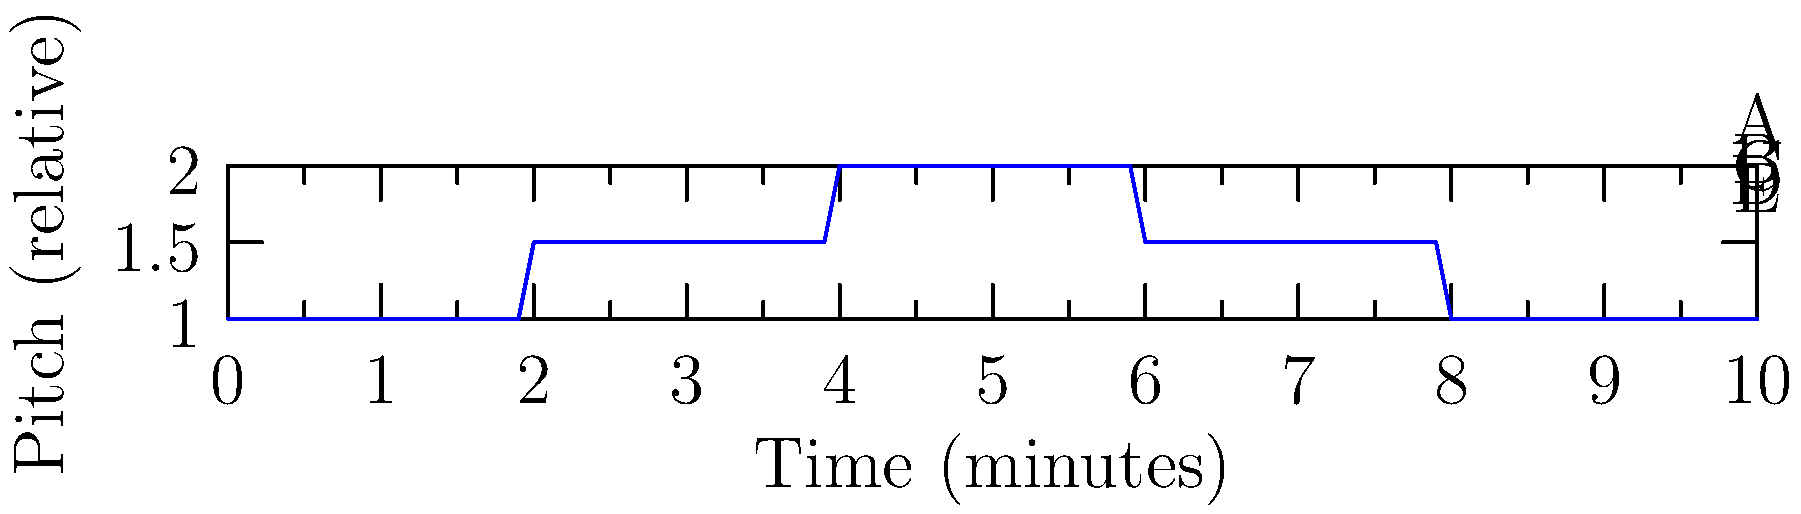In this graphical representation of a minimalist piece, how many distinct key changes occur throughout the composition? To determine the number of key changes in this minimalist piece, we need to analyze the graph step-by-step:

1. The graph represents pitch (relative to a base pitch) over time.
2. Changes in pitch level indicate potential key changes.
3. We start at pitch level 1 (section A).
4. At the 2-minute mark, the pitch rises to 1.5 (section B). This is the first key change.
5. At the 4-minute mark, the pitch rises to 2 (section C). This is the second key change.
6. At the 6-minute mark, the pitch drops back to 1.5 (section D). This is the third key change.
7. At the 8-minute mark, the pitch drops back to 1 (section E). This is the fourth key change.

In total, we observe 4 distinct key changes throughout the composition.

It's worth noting that in minimalist music, these subtle shifts might not always represent traditional key changes but could indicate changes in tonal center or modal shifts. However, for the purpose of this analysis, we're considering each distinct pitch level change as a key change.
Answer: 4 key changes 